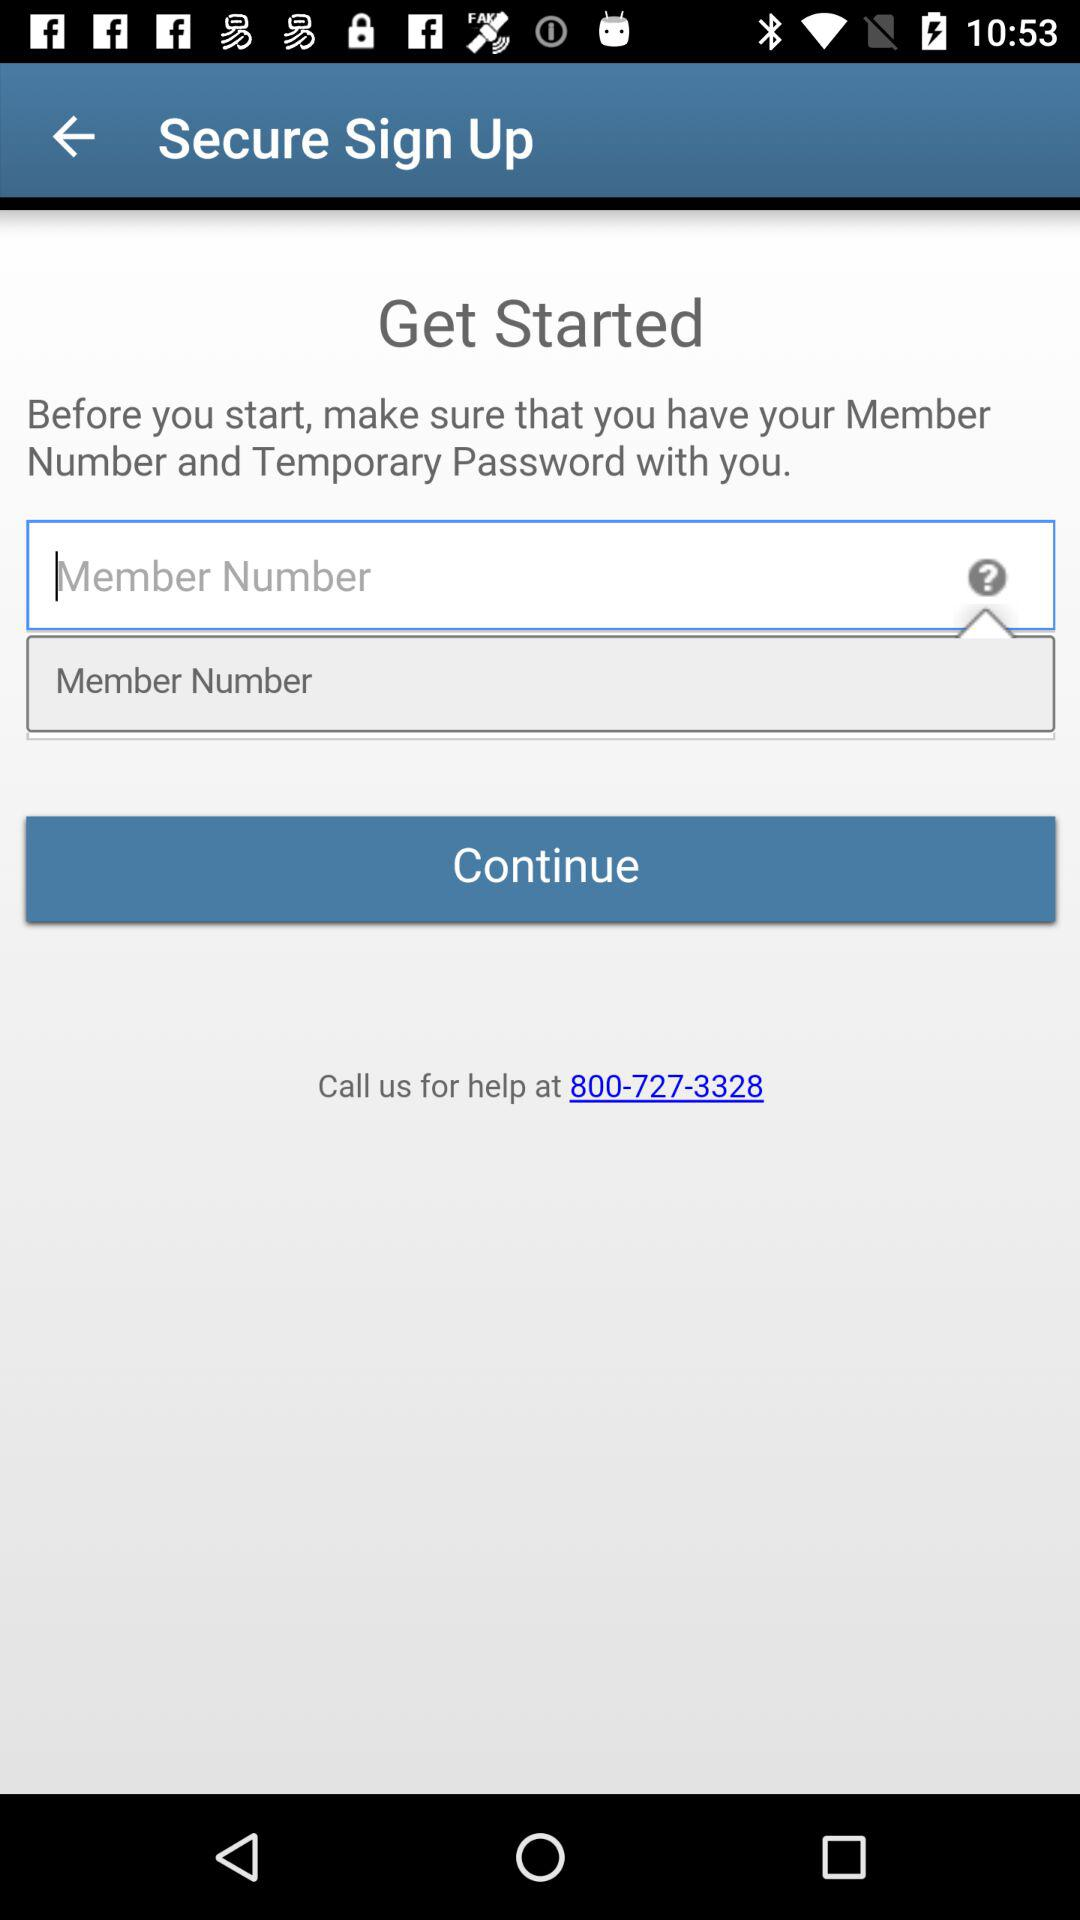How many input fields are there for entering personal information?
Answer the question using a single word or phrase. 2 